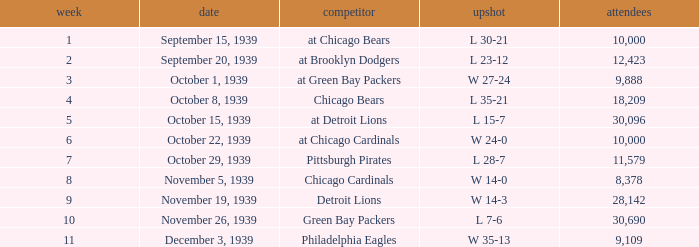Which Week has a Result of w 24-0, and an Attendance smaller than 10,000? None. 